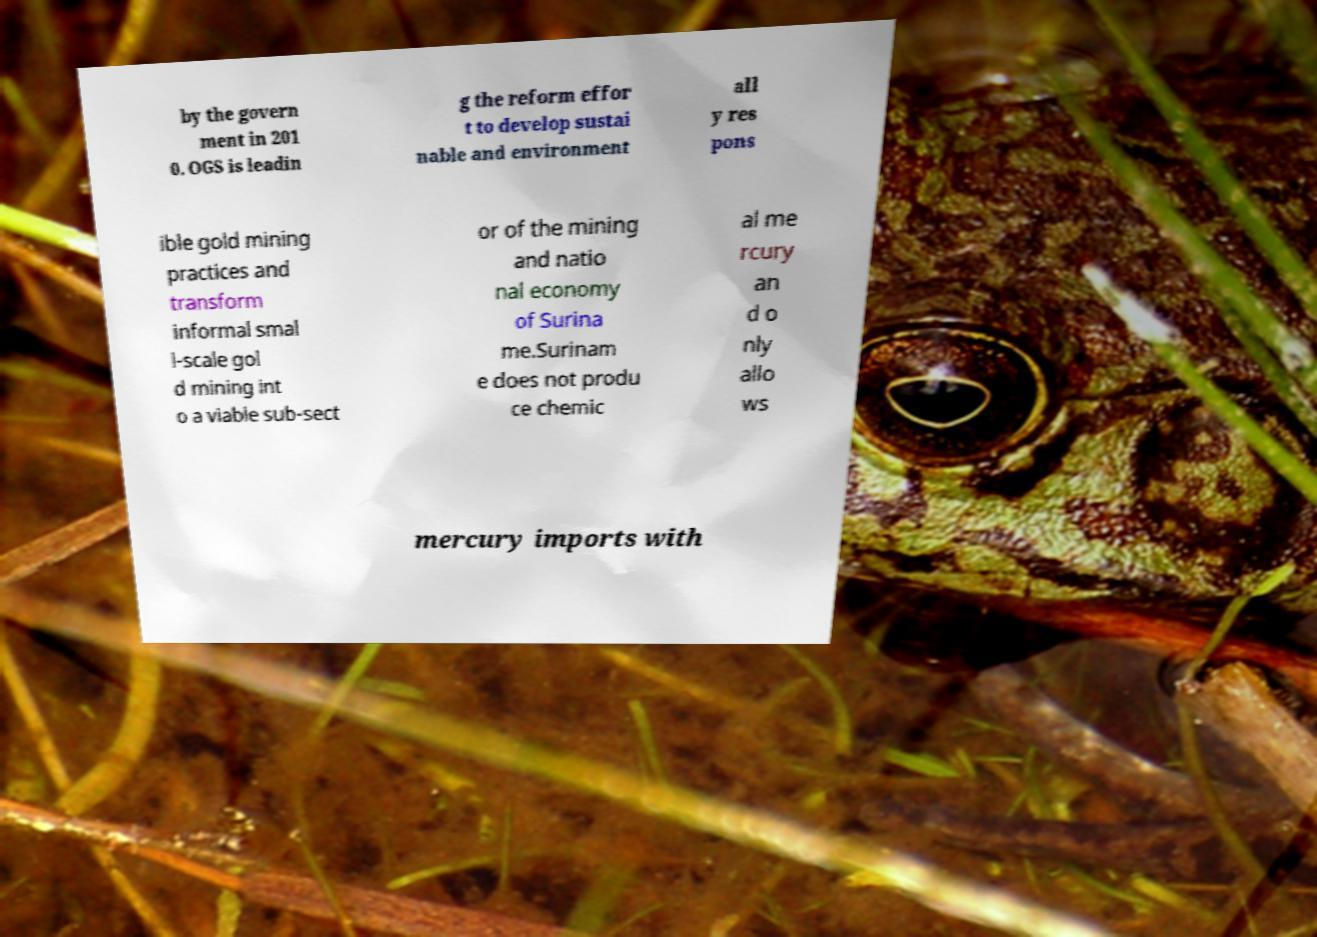Can you read and provide the text displayed in the image?This photo seems to have some interesting text. Can you extract and type it out for me? by the govern ment in 201 0. OGS is leadin g the reform effor t to develop sustai nable and environment all y res pons ible gold mining practices and transform informal smal l-scale gol d mining int o a viable sub-sect or of the mining and natio nal economy of Surina me.Surinam e does not produ ce chemic al me rcury an d o nly allo ws mercury imports with 